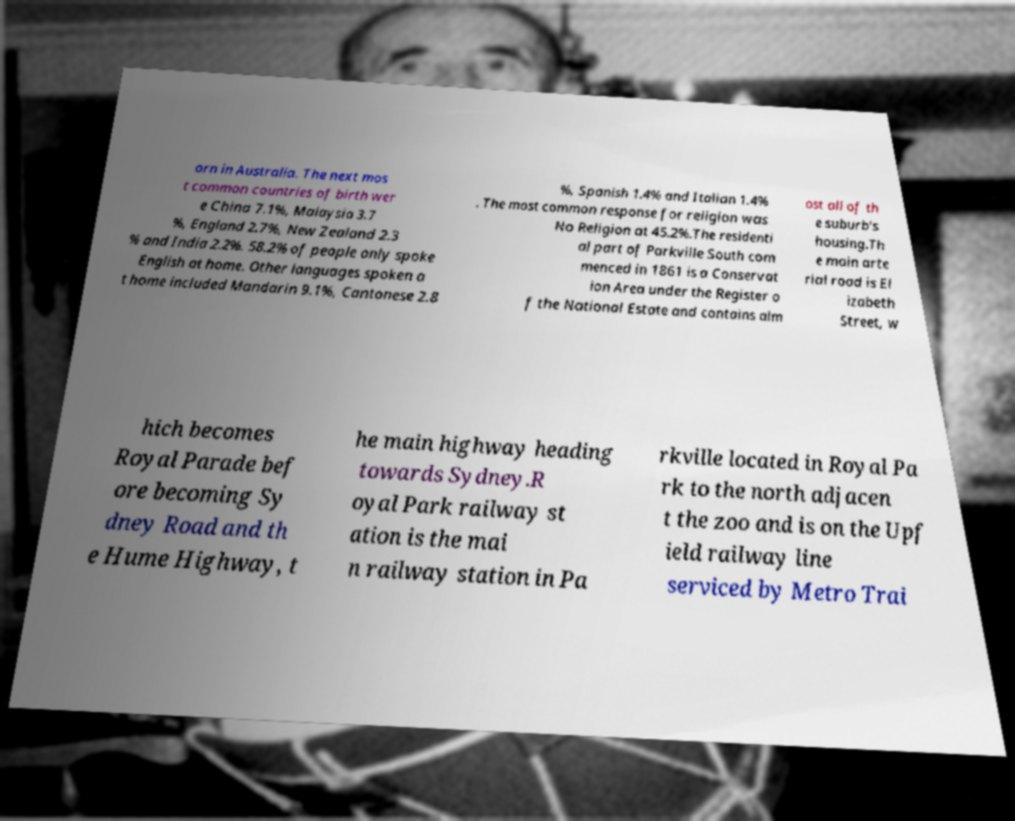Could you assist in decoding the text presented in this image and type it out clearly? orn in Australia. The next mos t common countries of birth wer e China 7.1%, Malaysia 3.7 %, England 2.7%, New Zealand 2.3 % and India 2.2%. 58.2% of people only spoke English at home. Other languages spoken a t home included Mandarin 9.1%, Cantonese 2.8 %, Spanish 1.4% and Italian 1.4% . The most common response for religion was No Religion at 45.2%.The residenti al part of Parkville South com menced in 1861 is a Conservat ion Area under the Register o f the National Estate and contains alm ost all of th e suburb's housing.Th e main arte rial road is El izabeth Street, w hich becomes Royal Parade bef ore becoming Sy dney Road and th e Hume Highway, t he main highway heading towards Sydney.R oyal Park railway st ation is the mai n railway station in Pa rkville located in Royal Pa rk to the north adjacen t the zoo and is on the Upf ield railway line serviced by Metro Trai 